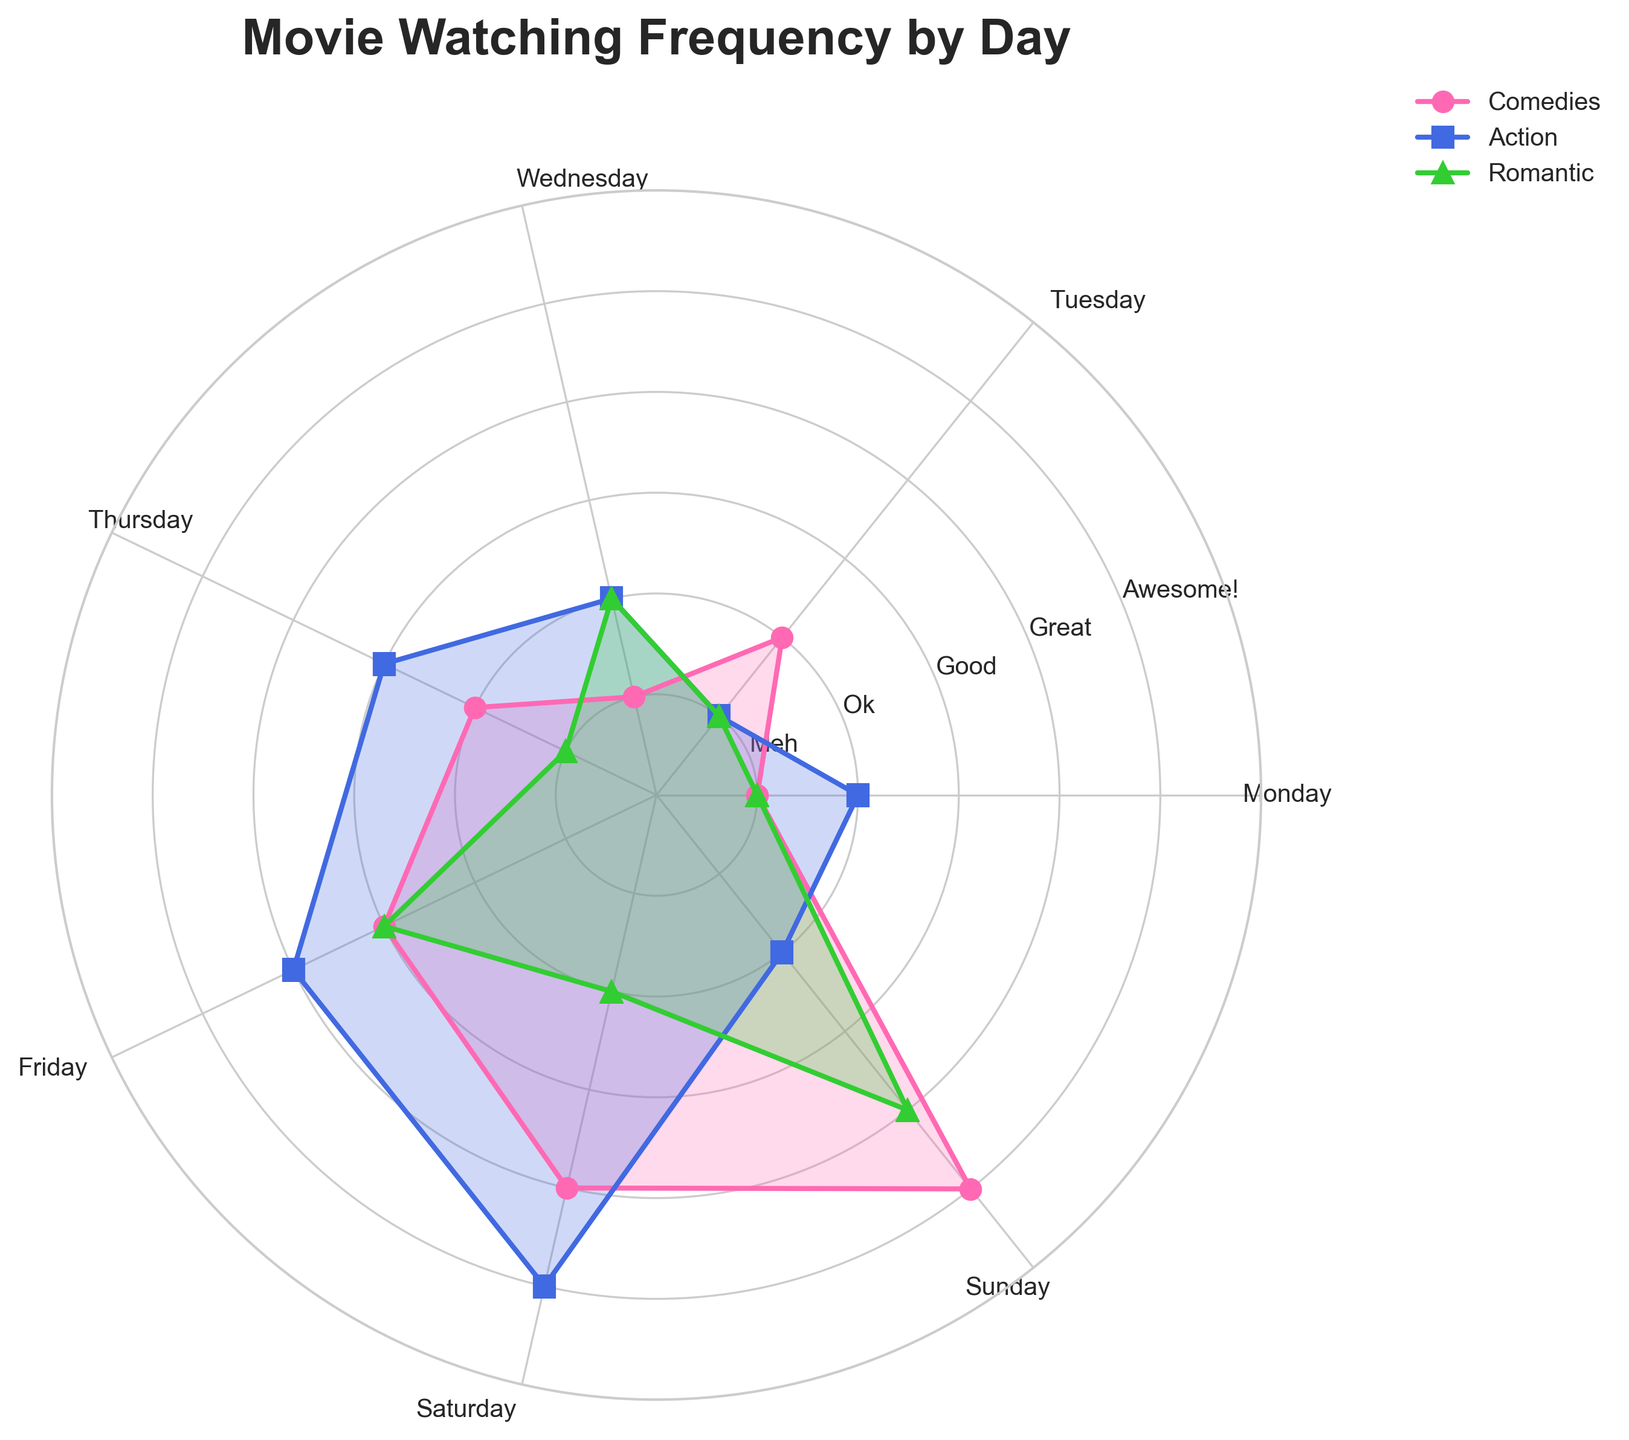Which movie genre is watched the most frequently on Sundays? Looking at the radar chart, the highest value for Sundays (the far-right portion of the plot) is for the Romantic genre, which reaches 4 on the scale.
Answer: Romantic Which day of the week has the highest frequency for watching Action movies? From the radar chart, the maximum value for Action movies occurs on Saturdays, with a score of 5.
Answer: Saturday What is the most popular genre on Fridays? On the radar chart, Fridays show values 3, 4, and 3 for Comedies, Action, and Romantic genres, respectively. Therefore, Action is the most popular genre on Fridays.
Answer: Action Which genre shows the most consistent watching frequency throughout the week? Observing the radar chart, the Comedies genre shows a gradual and consistent increase from Monday to Sunday without sudden spikes or drops.
Answer: Comedies On which days are Romantic movies watched more frequently than Comedies? By visually comparing the radar chart, Romantic movies have higher values on Wednesdays (2 vs. 1), Fridays (3 vs. 3, so considered tied), and Sundays (4 vs. 5), so technically, Sunday is higher for Romantic.
Answer: Wednesday, Friday, and Sunday How does the frequency of watching Comedies change from Monday to Sunday? The radar chart shows an increasing pattern for Comedies: Monday (1), Tuesday (2), Wednesday (1), Thursday (2), Friday (3), Saturday (4), and topping at Sunday (5).
Answer: Increases Which genre has the highest spike on any single day? The radar chart shows the highest spike for Action movies on Saturday, reaching a value of 5.
Answer: Action How do the watching patterns on the weekend (Saturday and Sunday) compare for Romantic movies? The chart indicates values of 2 for Saturday and 4 for Sunday for Romantic movies, showing that they are watched more on Sundays.
Answer: More on Sundays What is the total frequency of watching Comedies from Monday to Wednesday? Adding the values for Comedies on Monday (1), Tuesday (2), and Wednesday (1) gives a total of 1 + 2 + 1 = 4.
Answer: 4 Which day shows the highest combined frequency for all three genres? To find this, sum the values for each day: Sunday (Comedies: 5, Action: 2, Romantic: 4) totals 11, making it the highest combined frequency.
Answer: Sunday 